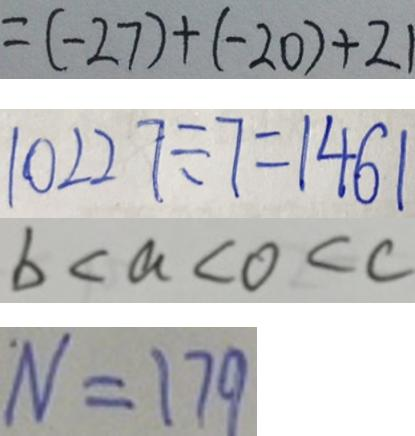<formula> <loc_0><loc_0><loc_500><loc_500>= ( - 2 7 ) + ( - 2 0 ) + 2 1 
 1 0 2 2 7 \div 7 = 1 4 6 1 
 b < a < o < c 
 N = 1 7 9</formula> 